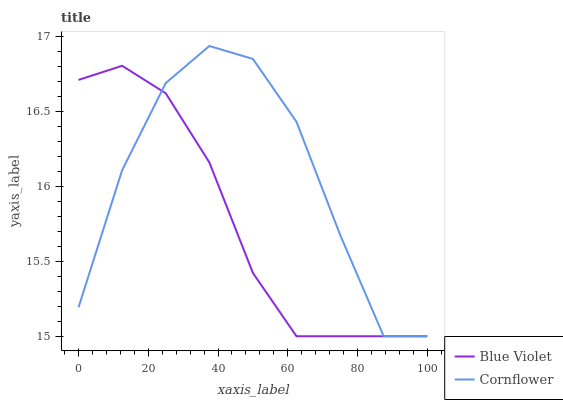Does Blue Violet have the minimum area under the curve?
Answer yes or no. Yes. Does Cornflower have the maximum area under the curve?
Answer yes or no. Yes. Does Blue Violet have the maximum area under the curve?
Answer yes or no. No. Is Blue Violet the smoothest?
Answer yes or no. Yes. Is Cornflower the roughest?
Answer yes or no. Yes. Is Blue Violet the roughest?
Answer yes or no. No. Does Cornflower have the lowest value?
Answer yes or no. Yes. Does Cornflower have the highest value?
Answer yes or no. Yes. Does Blue Violet have the highest value?
Answer yes or no. No. Does Blue Violet intersect Cornflower?
Answer yes or no. Yes. Is Blue Violet less than Cornflower?
Answer yes or no. No. Is Blue Violet greater than Cornflower?
Answer yes or no. No. 